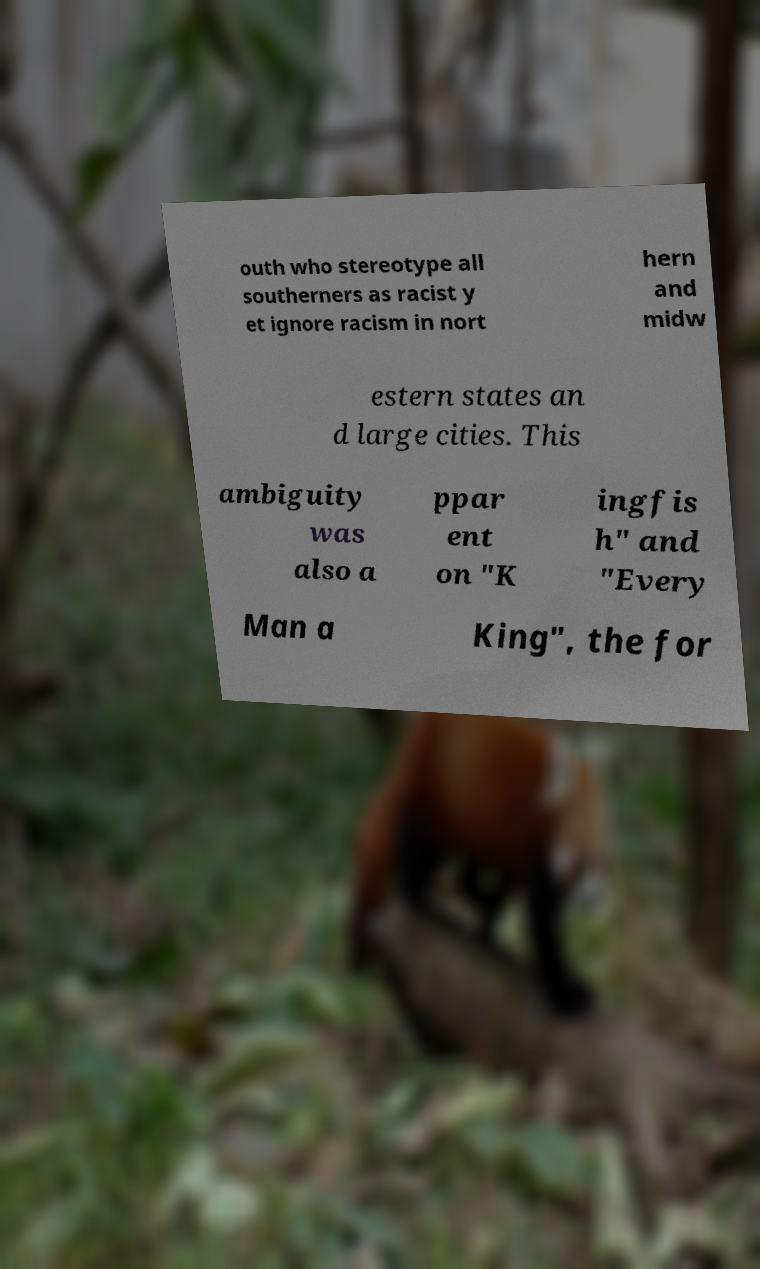For documentation purposes, I need the text within this image transcribed. Could you provide that? outh who stereotype all southerners as racist y et ignore racism in nort hern and midw estern states an d large cities. This ambiguity was also a ppar ent on "K ingfis h" and "Every Man a King", the for 